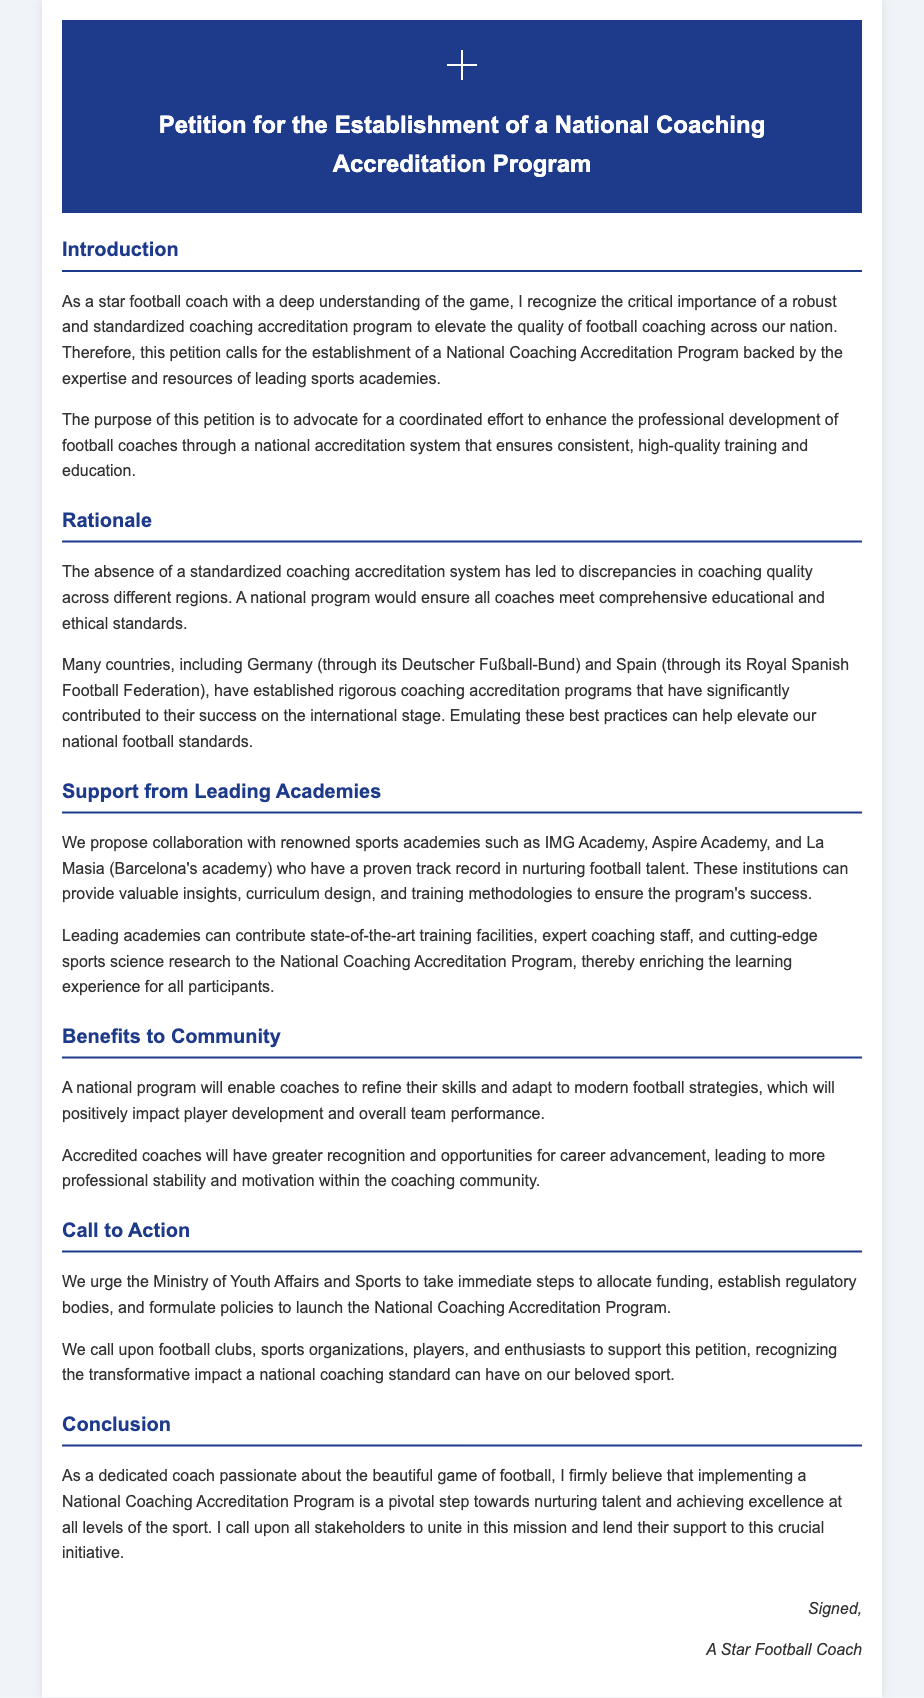What is the title of the petition? The title of the petition is stated at the top of the document.
Answer: Petition for the Establishment of a National Coaching Accreditation Program Who is urging the Ministry of Youth Affairs and Sports? The document indicates who is making the call to action towards the Ministry.
Answer: A Star Football Coach What is the purpose of the petition? The purpose of the petition is mentioned in the introduction of the document.
Answer: Advocate for a coordinated effort to enhance the professional development of football coaches Which academies are proposed for collaboration? The document lists specific academies proposed for collaboration.
Answer: IMG Academy, Aspire Academy, La Masia Which countries have established rigorous coaching accreditation programs? The document specifies countries that have successful programs in place.
Answer: Germany, Spain What benefits will a national program bring to coaches? The document elaborates on what advantages accredited coaches will experience.
Answer: Greater recognition and opportunities for career advancement What is the call to action in the petition? The specific action requested from stakeholders is outlined in the document.
Answer: Allocate funding, establish regulatory bodies, and formulate policies What is the main reasoning for establishing the program? The rationale for a national coaching accreditation program is provided in the document.
Answer: Discrepancies in coaching quality across different regions What is emphasized in the conclusion of the petition? The conclusion summarizes the petition's final thoughts.
Answer: Nurturing talent and achieving excellence at all levels of the sport 